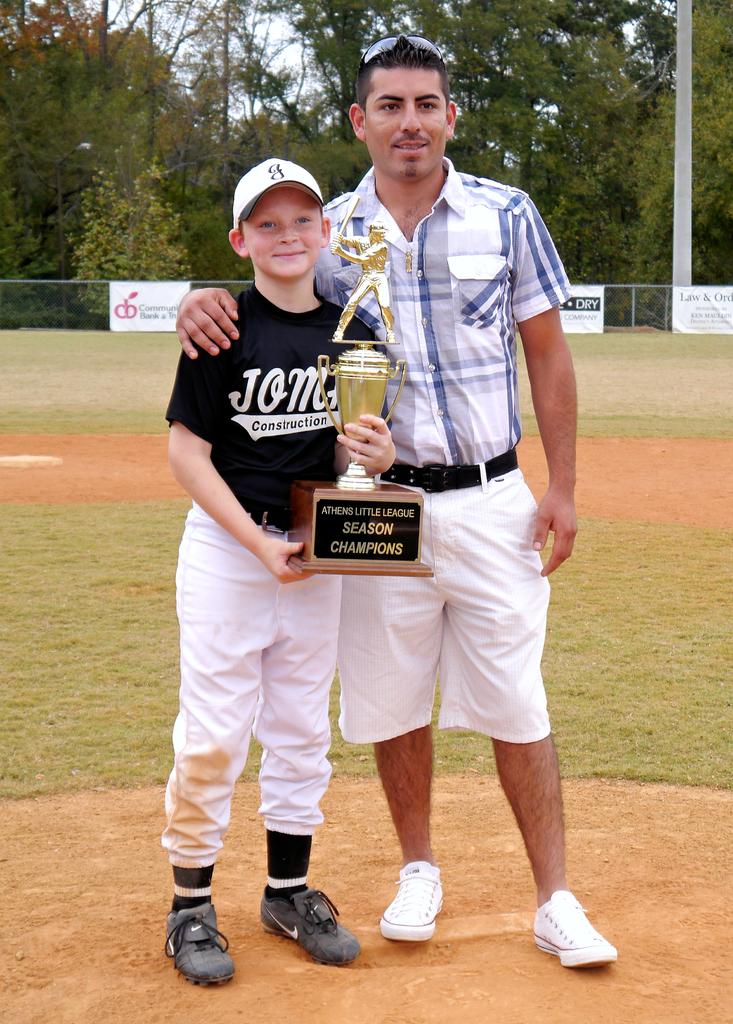What championship did they win?
Ensure brevity in your answer.  Athens little league. 